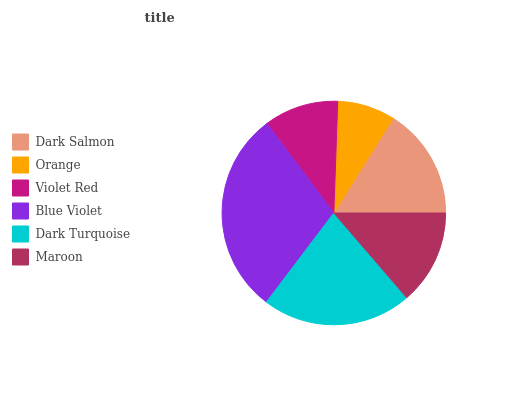Is Orange the minimum?
Answer yes or no. Yes. Is Blue Violet the maximum?
Answer yes or no. Yes. Is Violet Red the minimum?
Answer yes or no. No. Is Violet Red the maximum?
Answer yes or no. No. Is Violet Red greater than Orange?
Answer yes or no. Yes. Is Orange less than Violet Red?
Answer yes or no. Yes. Is Orange greater than Violet Red?
Answer yes or no. No. Is Violet Red less than Orange?
Answer yes or no. No. Is Dark Salmon the high median?
Answer yes or no. Yes. Is Maroon the low median?
Answer yes or no. Yes. Is Blue Violet the high median?
Answer yes or no. No. Is Dark Turquoise the low median?
Answer yes or no. No. 